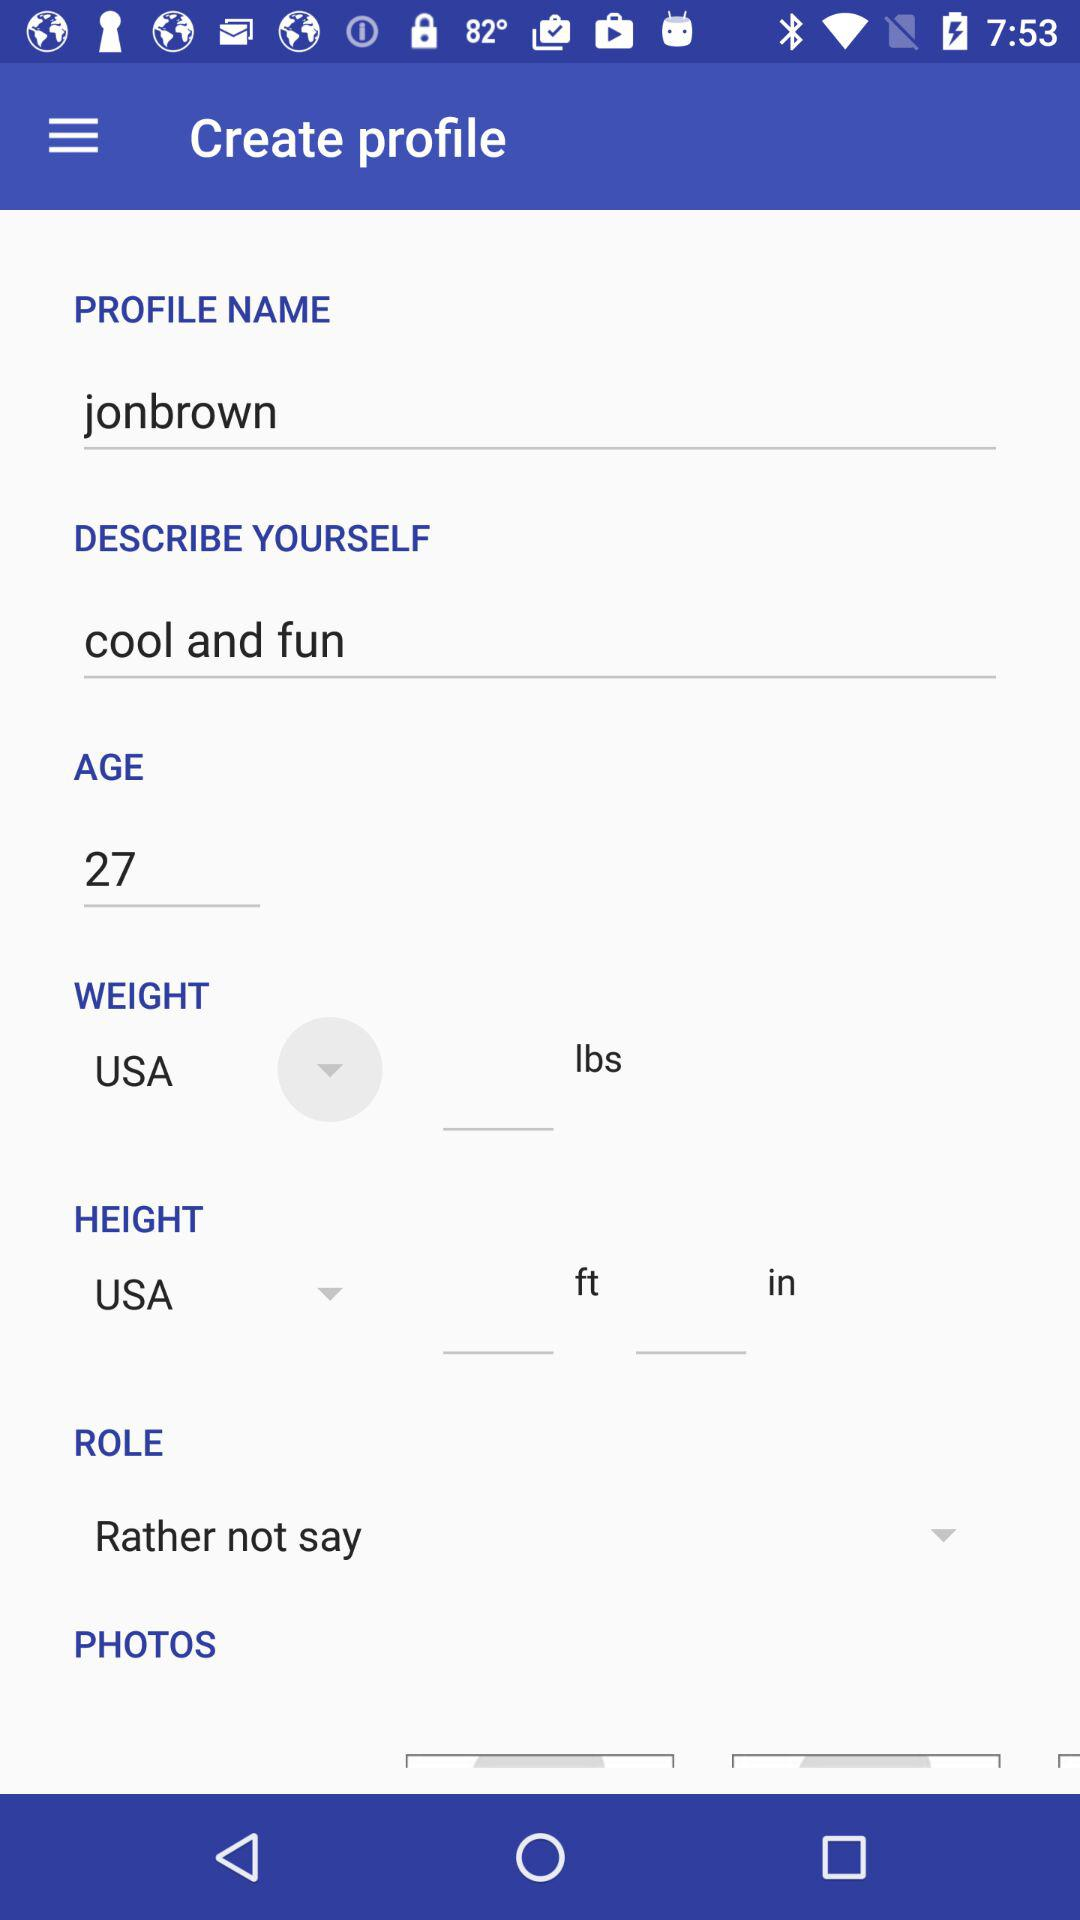What is the role of the user? The role of the user is "Rather not say". 